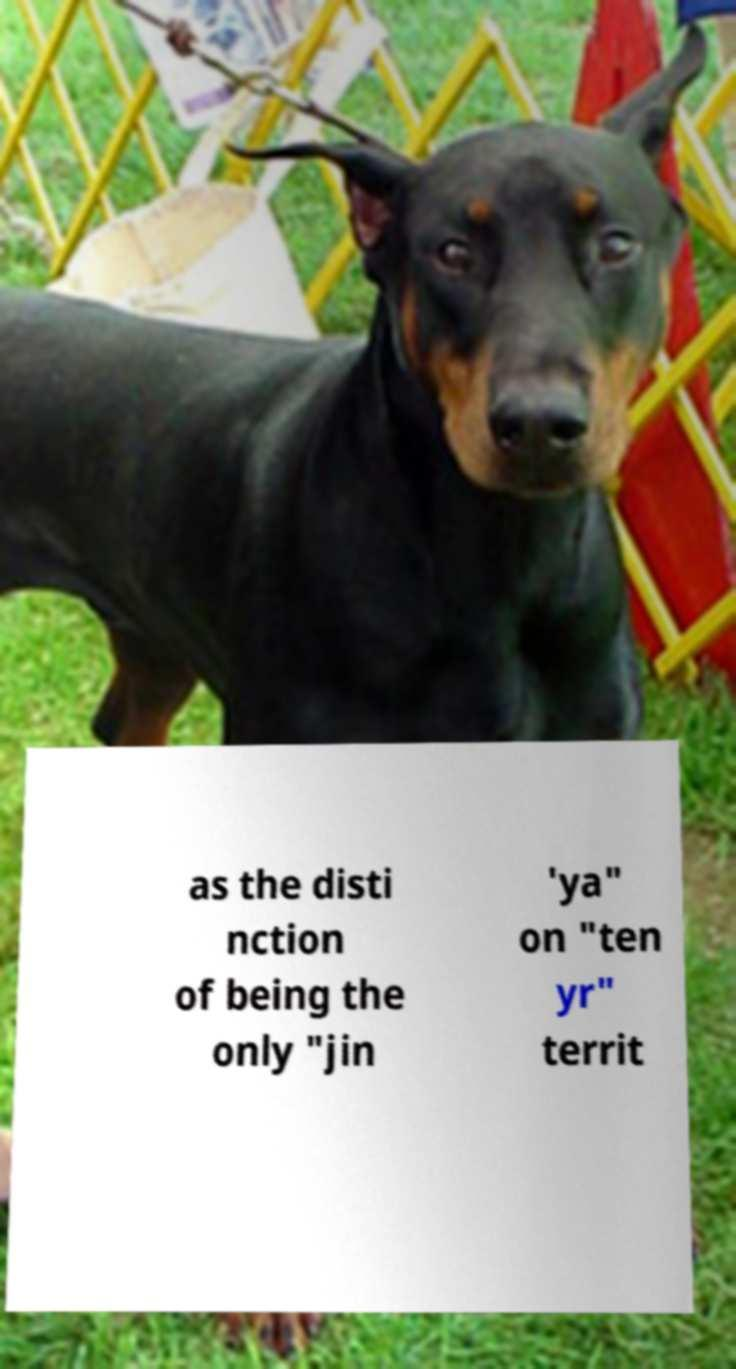Please read and relay the text visible in this image. What does it say? as the disti nction of being the only "jin 'ya" on "ten yr" territ 